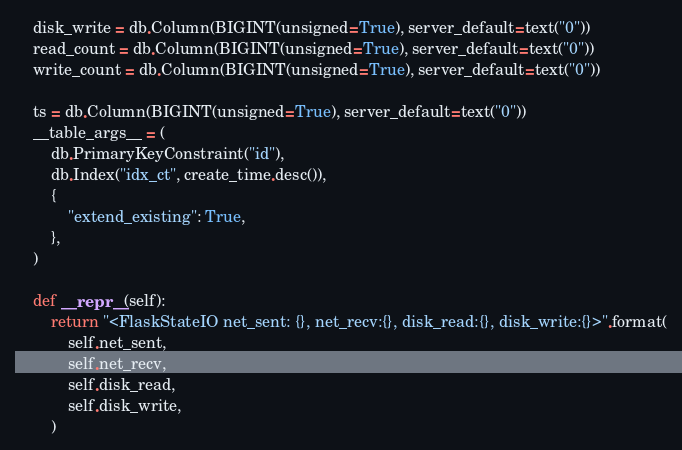Convert code to text. <code><loc_0><loc_0><loc_500><loc_500><_Python_>    disk_write = db.Column(BIGINT(unsigned=True), server_default=text("0"))
    read_count = db.Column(BIGINT(unsigned=True), server_default=text("0"))
    write_count = db.Column(BIGINT(unsigned=True), server_default=text("0"))

    ts = db.Column(BIGINT(unsigned=True), server_default=text("0"))
    __table_args__ = (
        db.PrimaryKeyConstraint("id"),
        db.Index("idx_ct", create_time.desc()),
        {
            "extend_existing": True,
        },
    )

    def __repr__(self):
        return "<FlaskStateIO net_sent: {}, net_recv:{}, disk_read:{}, disk_write:{}>".format(
            self.net_sent,
            self.net_recv,
            self.disk_read,
            self.disk_write,
        )
</code> 